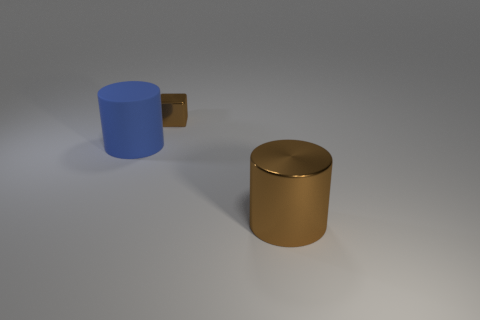How many objects are either shiny objects behind the matte thing or brown cylinders?
Your response must be concise. 2. The brown thing that is to the left of the large thing that is on the right side of the large thing that is left of the brown cylinder is what shape?
Provide a short and direct response. Cube. How many big brown metal objects have the same shape as the large blue rubber object?
Give a very brief answer. 1. What is the material of the other thing that is the same color as the small metal object?
Provide a short and direct response. Metal. Do the tiny brown object and the big blue thing have the same material?
Make the answer very short. No. There is a thing that is in front of the cylinder that is to the left of the tiny metal block; how many blue matte cylinders are right of it?
Provide a succinct answer. 0. Is there a cyan sphere that has the same material as the tiny brown block?
Provide a short and direct response. No. What is the size of the metal block that is the same color as the large metallic thing?
Give a very brief answer. Small. Is the number of big brown things less than the number of green things?
Offer a very short reply. No. There is a cylinder in front of the matte cylinder; is it the same color as the tiny metal block?
Provide a short and direct response. Yes. 